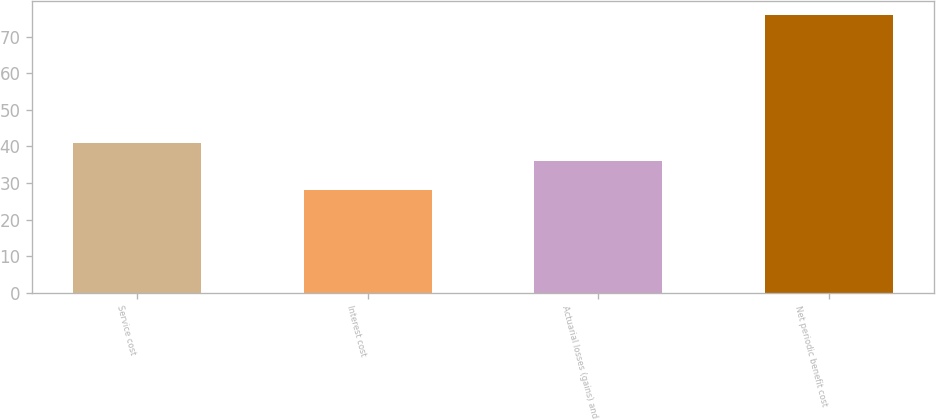Convert chart to OTSL. <chart><loc_0><loc_0><loc_500><loc_500><bar_chart><fcel>Service cost<fcel>Interest cost<fcel>Actuarial losses (gains) and<fcel>Net periodic benefit cost<nl><fcel>40.8<fcel>28<fcel>36<fcel>76<nl></chart> 